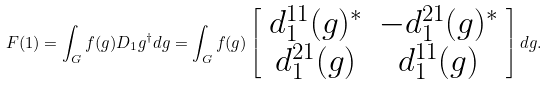<formula> <loc_0><loc_0><loc_500><loc_500>F ( 1 ) = \int _ { G } f ( g ) D _ { 1 } { g } ^ { \dagger } d g = \int _ { G } f ( g ) \left [ \begin{array} { c c } d _ { 1 } ^ { 1 1 } ( g ) ^ { * } & - d _ { 1 } ^ { 2 1 } ( g ) ^ { * } \\ d _ { 1 } ^ { 2 1 } ( g ) & d _ { 1 } ^ { 1 1 } ( g ) \end{array} \right ] d g .</formula> 